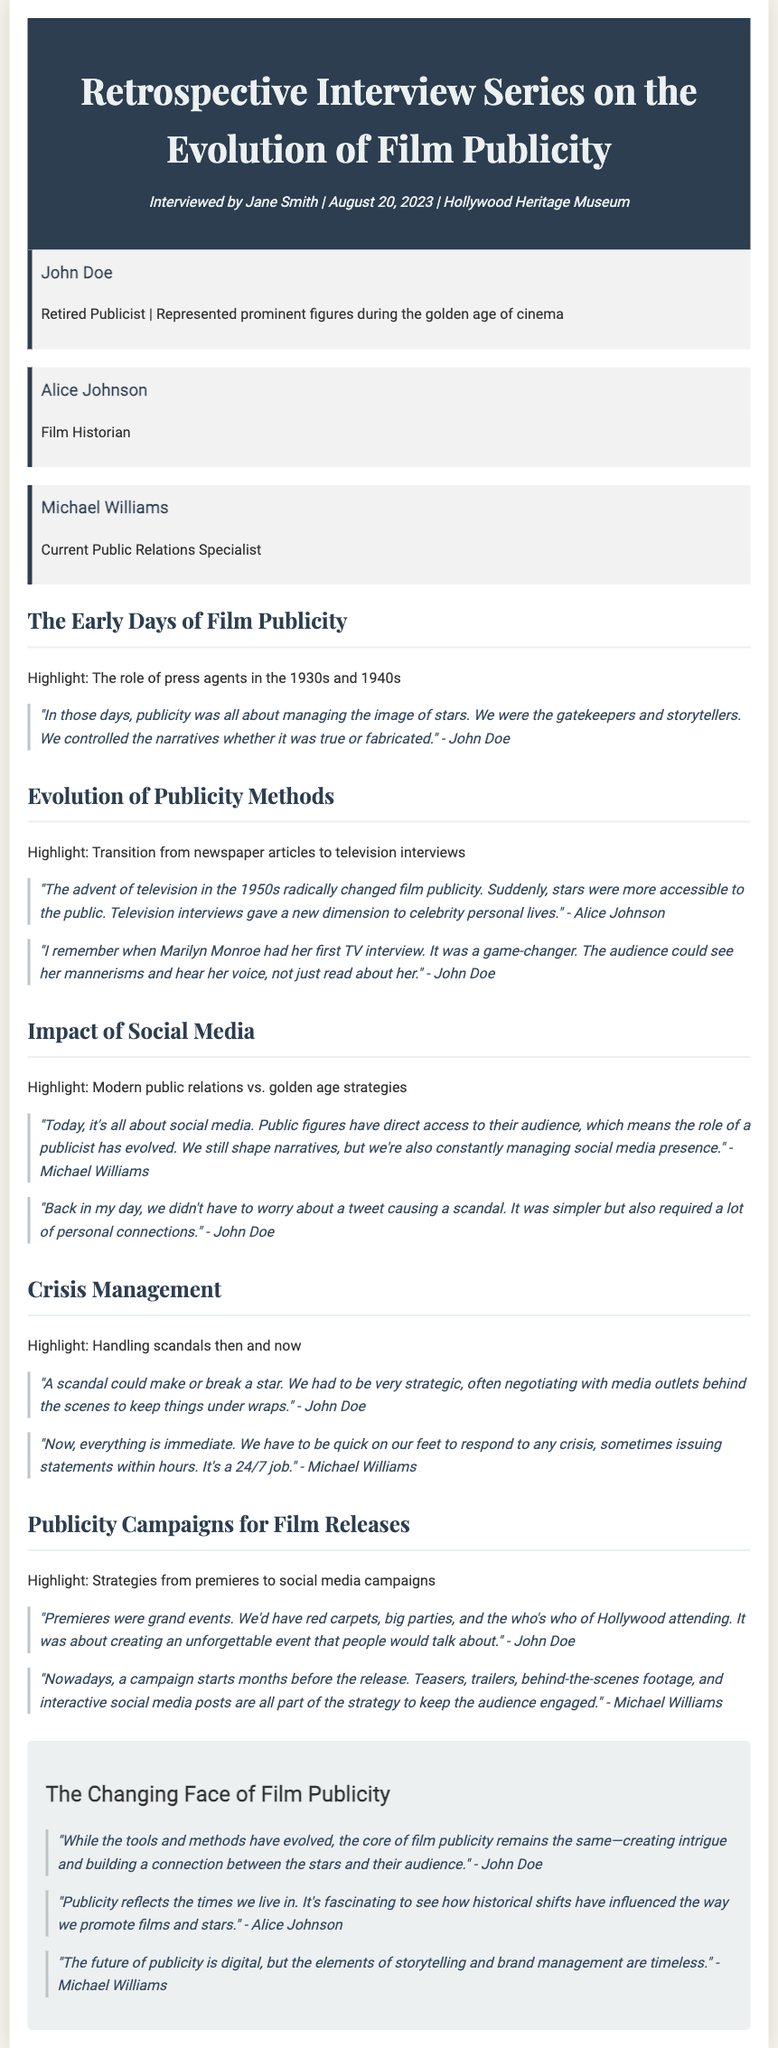What date was the interview conducted? The document specifies that the interview took place on August 20, 2023.
Answer: August 20, 2023 Who interviewed the participants? The interview was conducted by Jane Smith, as mentioned in the header.
Answer: Jane Smith What role did John Doe have during the golden age of cinema? According to the document, John Doe was a retired publicist who represented prominent figures during that era.
Answer: Retired Publicist Which publicist referred to Marilyn Monroe's first TV interview as a game-changer? The quote in the document indicates that John Doe made this reference about Marilyn Monroe's interview.
Answer: John Doe What was a key change in film publicity noted by Alice Johnson regarding the 1950s? Alice Johnson highlighted that the advent of television radically changed film publicity during that time.
Answer: Television What does Michael Williams say about the 24/7 nature of public relations today? He notes that crisis management requires quick responses, sometimes issuing statements within hours, indicating the demands of modern publicity roles.
Answer: 24/7 job Which section discusses the grandeur of film premieres? The section titled "Publicity Campaigns for Film Releases" covers the strategies involving grand events like film premieres.
Answer: Publicity Campaigns for Film Releases How does John Doe summarize the core of film publicity? John Doe states that, despite evolving tools, the essence of film publicity is about creating intrigue and connection.
Answer: Creating intrigue and building a connection What change in strategy is highlighted regarding modern publicity campaigns compared to the past? The document notes that modern campaigns start months before a film's release, contrasting with past approaches.
Answer: Starts months before release 